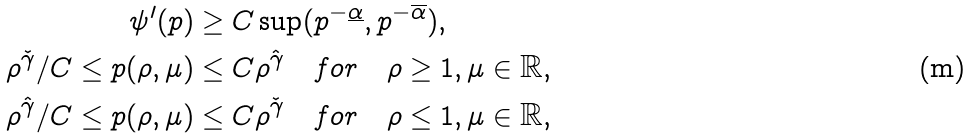Convert formula to latex. <formula><loc_0><loc_0><loc_500><loc_500>\psi ^ { \prime } ( p ) \geq C & \sup ( p ^ { - \underline { \alpha } } , p ^ { - \overline { \alpha } } ) , \\ \rho ^ { \check { \gamma } } / C \leq p ( \rho , \mu ) \leq C & \rho ^ { \hat { \gamma } } \quad f o r \quad \rho \geq 1 , \mu \in \mathbb { R } , \\ \rho ^ { \hat { \gamma } } / C \leq p ( \rho , \mu ) \leq C & \rho ^ { \check { \gamma } } \quad f o r \quad \rho \leq 1 , \mu \in \mathbb { R } ,</formula> 